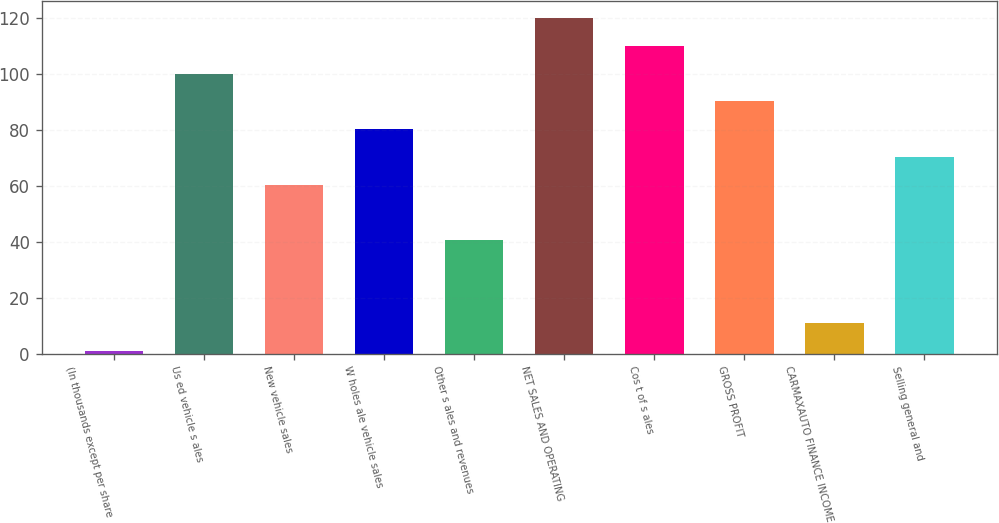<chart> <loc_0><loc_0><loc_500><loc_500><bar_chart><fcel>(In thousands except per share<fcel>Us ed vehicle s ales<fcel>New vehicle sales<fcel>W holes ale vehicle sales<fcel>Other s ales and revenues<fcel>NET SALES AND OPERATING<fcel>Cos t of s ales<fcel>GROSS PROFIT<fcel>CARMAXAUTO FINANCE INCOME<fcel>Selling general and<nl><fcel>1<fcel>100<fcel>60.4<fcel>80.2<fcel>40.6<fcel>119.8<fcel>109.9<fcel>90.1<fcel>10.9<fcel>70.3<nl></chart> 